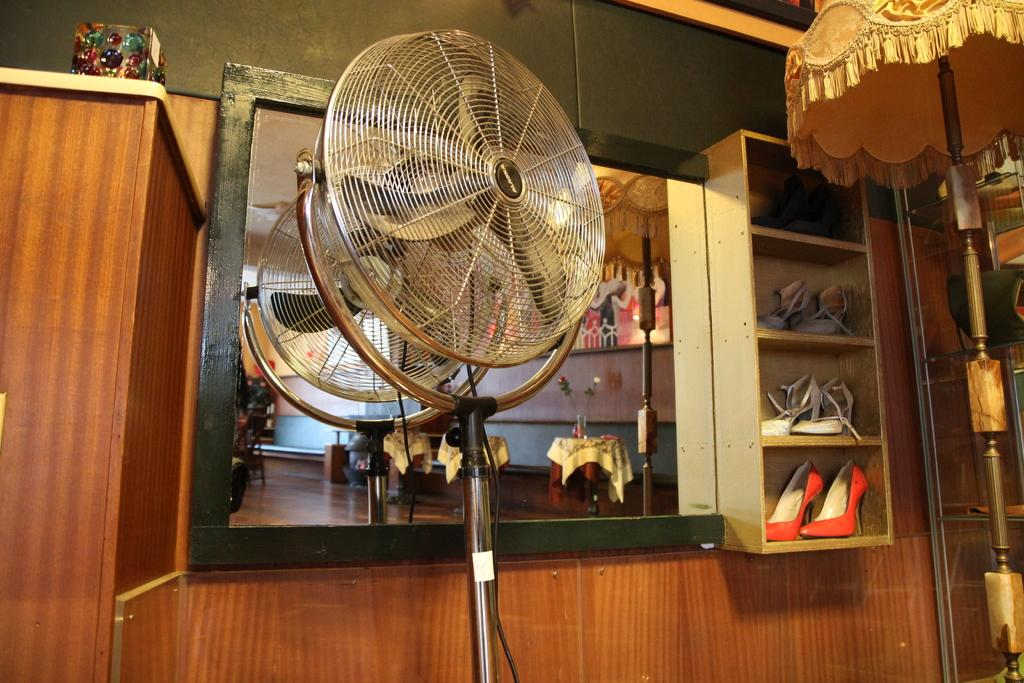What type of appliance is visible in the image? There is a fan in the image. What can be used for personal grooming in the image? There is a mirror in the image. Where are the sandals located in the image? The sandals are in a rack in the image. What is the background of the image made of? There is a wall in the image. Can you describe the objects present in the image? There are some objects in the image, but their specific nature is not mentioned in the facts. How much dust is visible on the land in the image? There is no mention of dust or land in the image; it features a fan, a mirror, sandals in a rack, and a wall. 